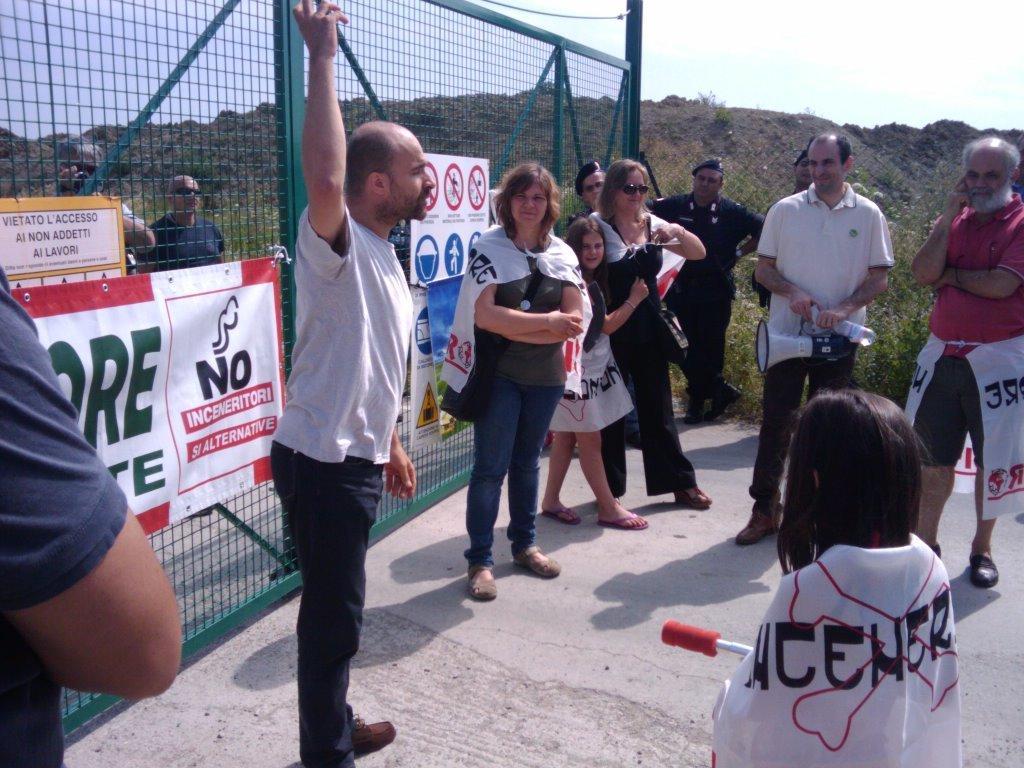Describe this image in one or two sentences. In this image, we can see people standing and some of them are wearing bags and clothes and we can see some people holding some objects. In the background, we can see banners to a mesh and there are hills. At the bottom, there is road and at the top, there is sky. 